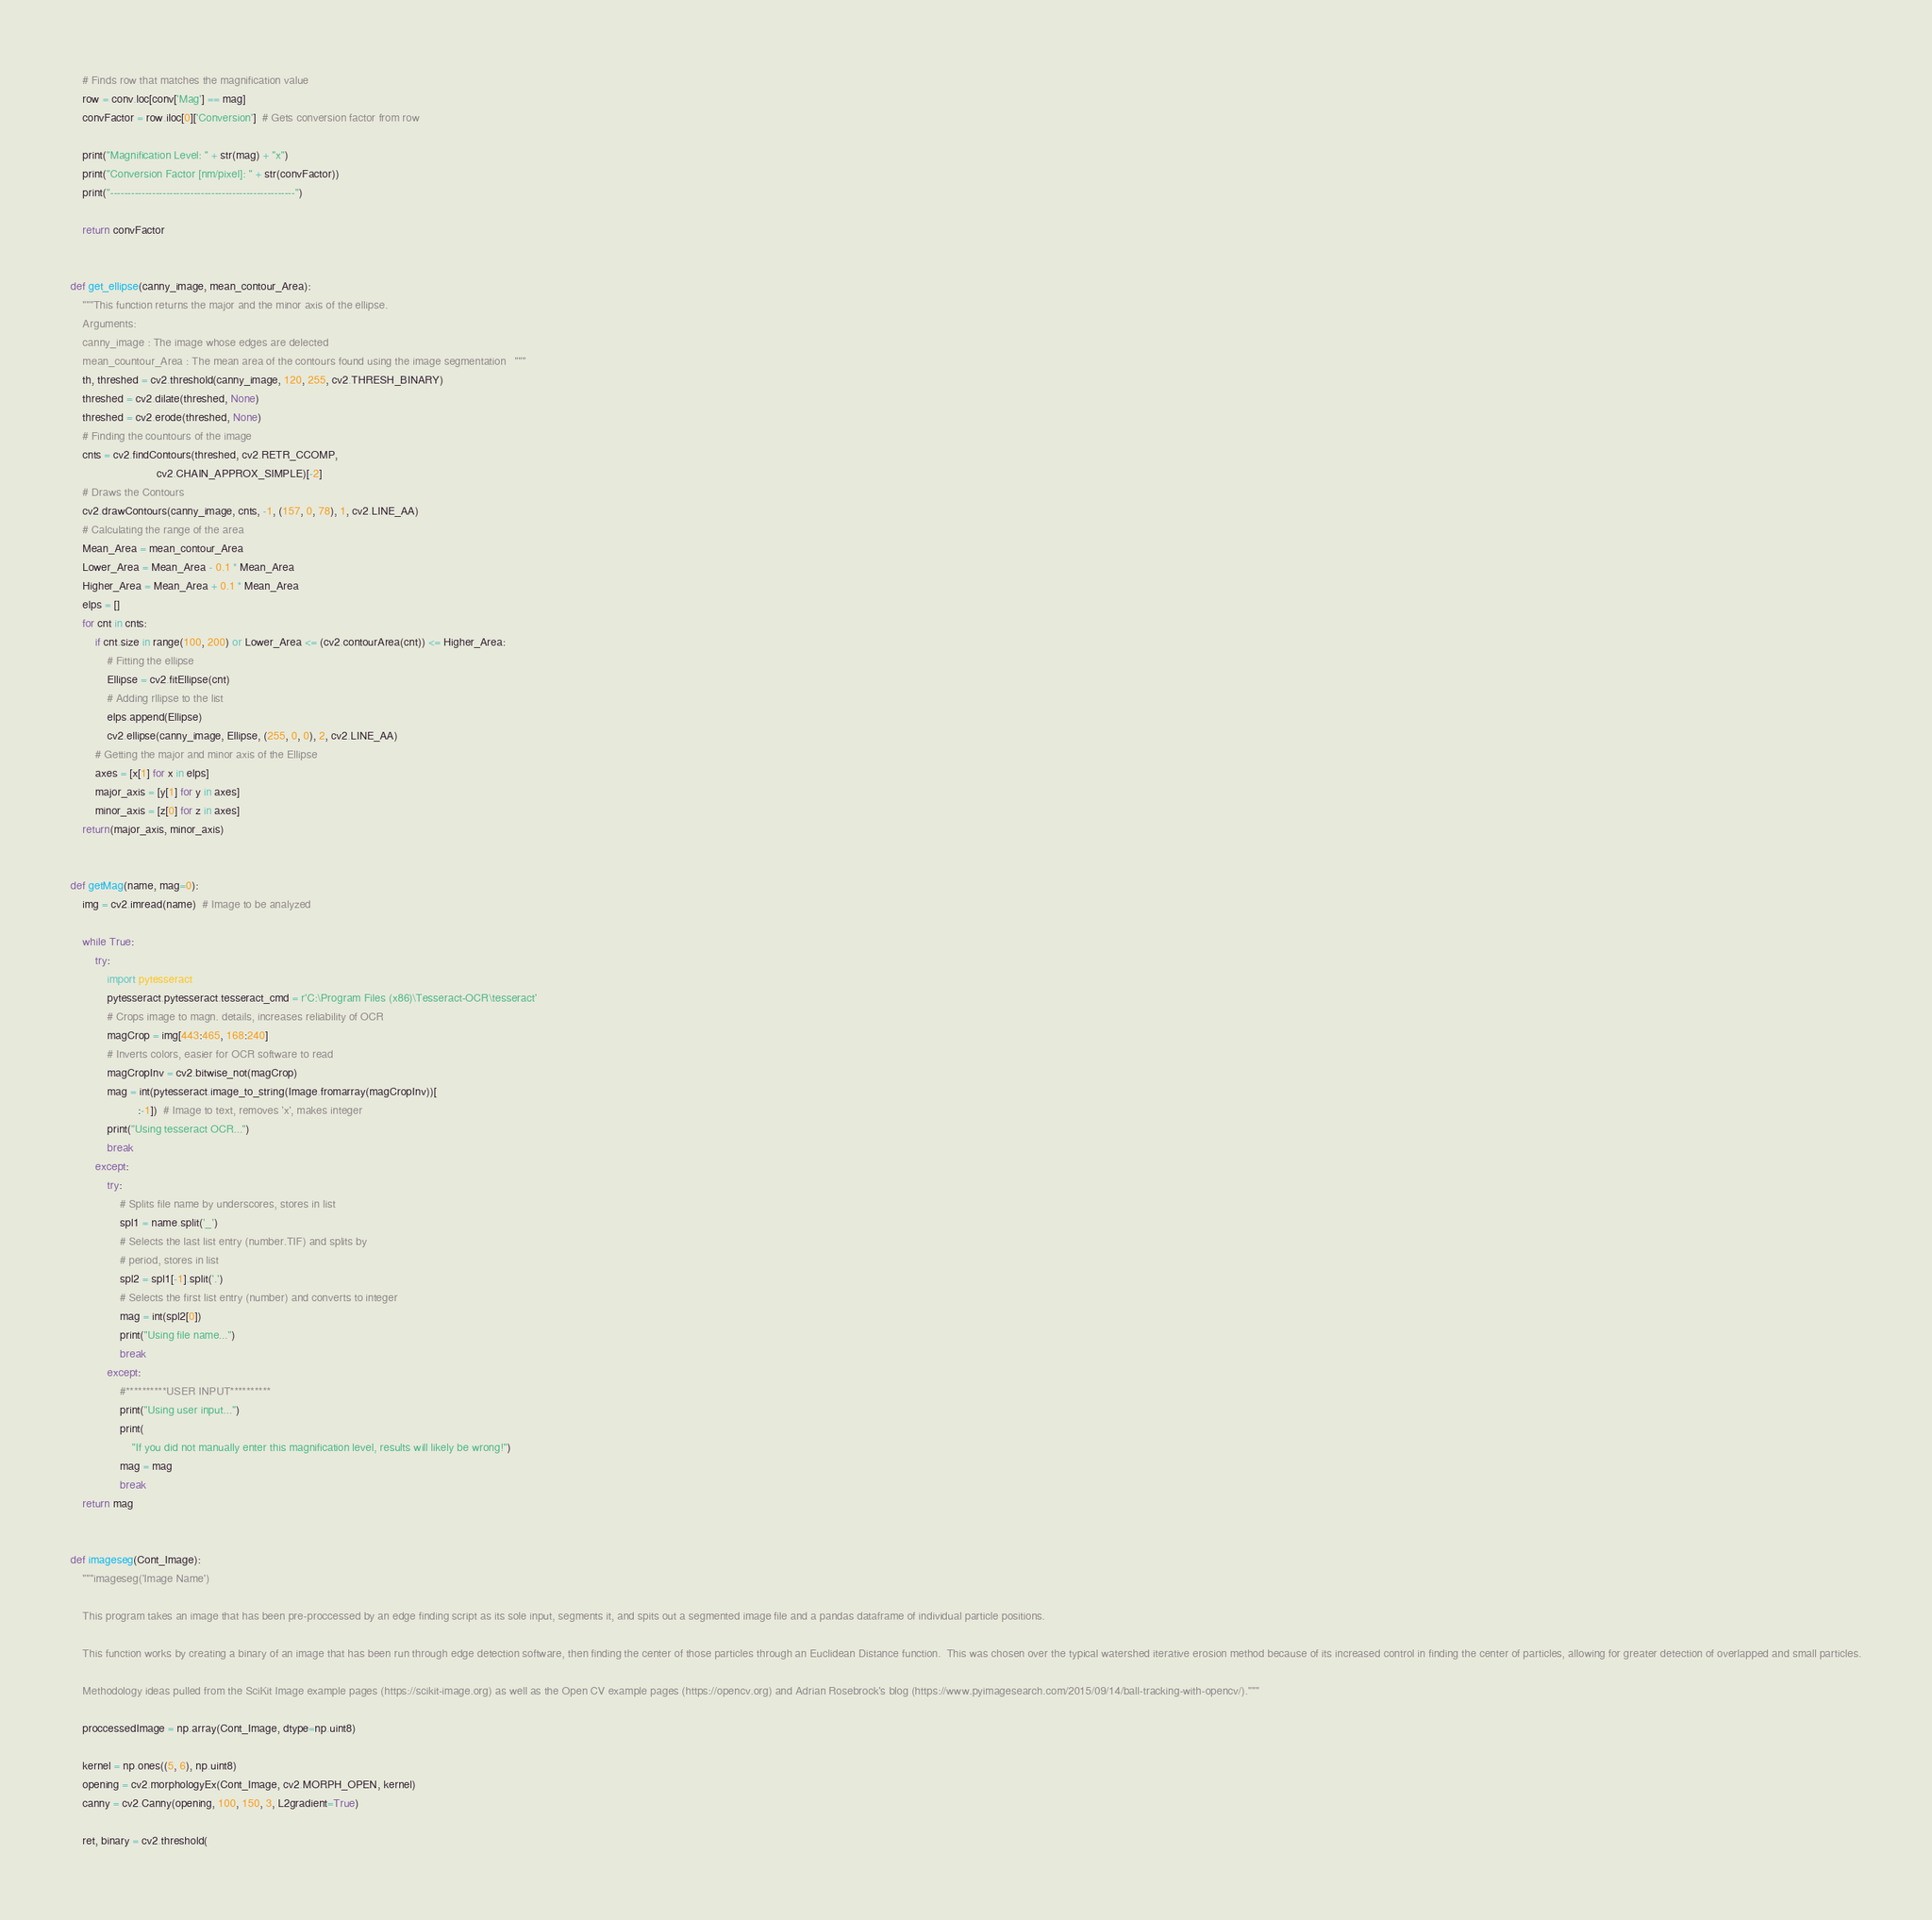Convert code to text. <code><loc_0><loc_0><loc_500><loc_500><_Python_>    # Finds row that matches the magnification value
    row = conv.loc[conv['Mag'] == mag]
    convFactor = row.iloc[0]['Conversion']  # Gets conversion factor from row

    print("Magnification Level: " + str(mag) + "x")
    print("Conversion Factor [nm/pixel]: " + str(convFactor))
    print("-----------------------------------------------------")

    return convFactor


def get_ellipse(canny_image, mean_contour_Area):
    """This function returns the major and the minor axis of the ellipse.
    Arguments:
    canny_image : The image whose edges are delected
    mean_countour_Area : The mean area of the contours found using the image segmentation   """
    th, threshed = cv2.threshold(canny_image, 120, 255, cv2.THRESH_BINARY)
    threshed = cv2.dilate(threshed, None)
    threshed = cv2.erode(threshed, None)
    # Finding the countours of the image
    cnts = cv2.findContours(threshed, cv2.RETR_CCOMP,
                            cv2.CHAIN_APPROX_SIMPLE)[-2]
    # Draws the Contours
    cv2.drawContours(canny_image, cnts, -1, (157, 0, 78), 1, cv2.LINE_AA)
    # Calculating the range of the area
    Mean_Area = mean_contour_Area
    Lower_Area = Mean_Area - 0.1 * Mean_Area
    Higher_Area = Mean_Area + 0.1 * Mean_Area
    elps = []
    for cnt in cnts:
        if cnt.size in range(100, 200) or Lower_Area <= (cv2.contourArea(cnt)) <= Higher_Area:
            # Fitting the ellipse
            Ellipse = cv2.fitEllipse(cnt)
            # Adding rllipse to the list
            elps.append(Ellipse)
            cv2.ellipse(canny_image, Ellipse, (255, 0, 0), 2, cv2.LINE_AA)
        # Getting the major and minor axis of the Ellipse
        axes = [x[1] for x in elps]
        major_axis = [y[1] for y in axes]
        minor_axis = [z[0] for z in axes]
    return(major_axis, minor_axis)


def getMag(name, mag=0):
    img = cv2.imread(name)  # Image to be analyzed

    while True:
        try:
            import pytesseract
            pytesseract.pytesseract.tesseract_cmd = r'C:\Program Files (x86)\Tesseract-OCR\tesseract'
            # Crops image to magn. details, increases reliability of OCR
            magCrop = img[443:465, 168:240]
            # Inverts colors, easier for OCR software to read
            magCropInv = cv2.bitwise_not(magCrop)
            mag = int(pytesseract.image_to_string(Image.fromarray(magCropInv))[
                      :-1])  # Image to text, removes 'x', makes integer
            print("Using tesseract OCR...")
            break
        except:
            try:
                # Splits file name by underscores, stores in list
                spl1 = name.split('_')
                # Selects the last list entry (number.TIF) and splits by
                # period, stores in list
                spl2 = spl1[-1].split('.')
                # Selects the first list entry (number) and converts to integer
                mag = int(spl2[0])
                print("Using file name...")
                break
            except:
                #**********USER INPUT**********
                print("Using user input...")
                print(
                    "If you did not manually enter this magnification level, results will likely be wrong!")
                mag = mag
                break
    return mag


def imageseg(Cont_Image):
    """imageseg('Image Name')

    This program takes an image that has been pre-proccessed by an edge finding script as its sole input, segments it, and spits out a segmented image file and a pandas dataframe of individual particle positions.

    This function works by creating a binary of an image that has been run through edge detection software, then finding the center of those particles through an Euclidean Distance function.  This was chosen over the typical watershed iterative erosion method because of its increased control in finding the center of particles, allowing for greater detection of overlapped and small particles.

    Methodology ideas pulled from the SciKit Image example pages (https://scikit-image.org) as well as the Open CV example pages (https://opencv.org) and Adrian Rosebrock's blog (https://www.pyimagesearch.com/2015/09/14/ball-tracking-with-opencv/)."""

    proccessedImage = np.array(Cont_Image, dtype=np.uint8)

    kernel = np.ones((5, 6), np.uint8)
    opening = cv2.morphologyEx(Cont_Image, cv2.MORPH_OPEN, kernel)
    canny = cv2.Canny(opening, 100, 150, 3, L2gradient=True)

    ret, binary = cv2.threshold(</code> 